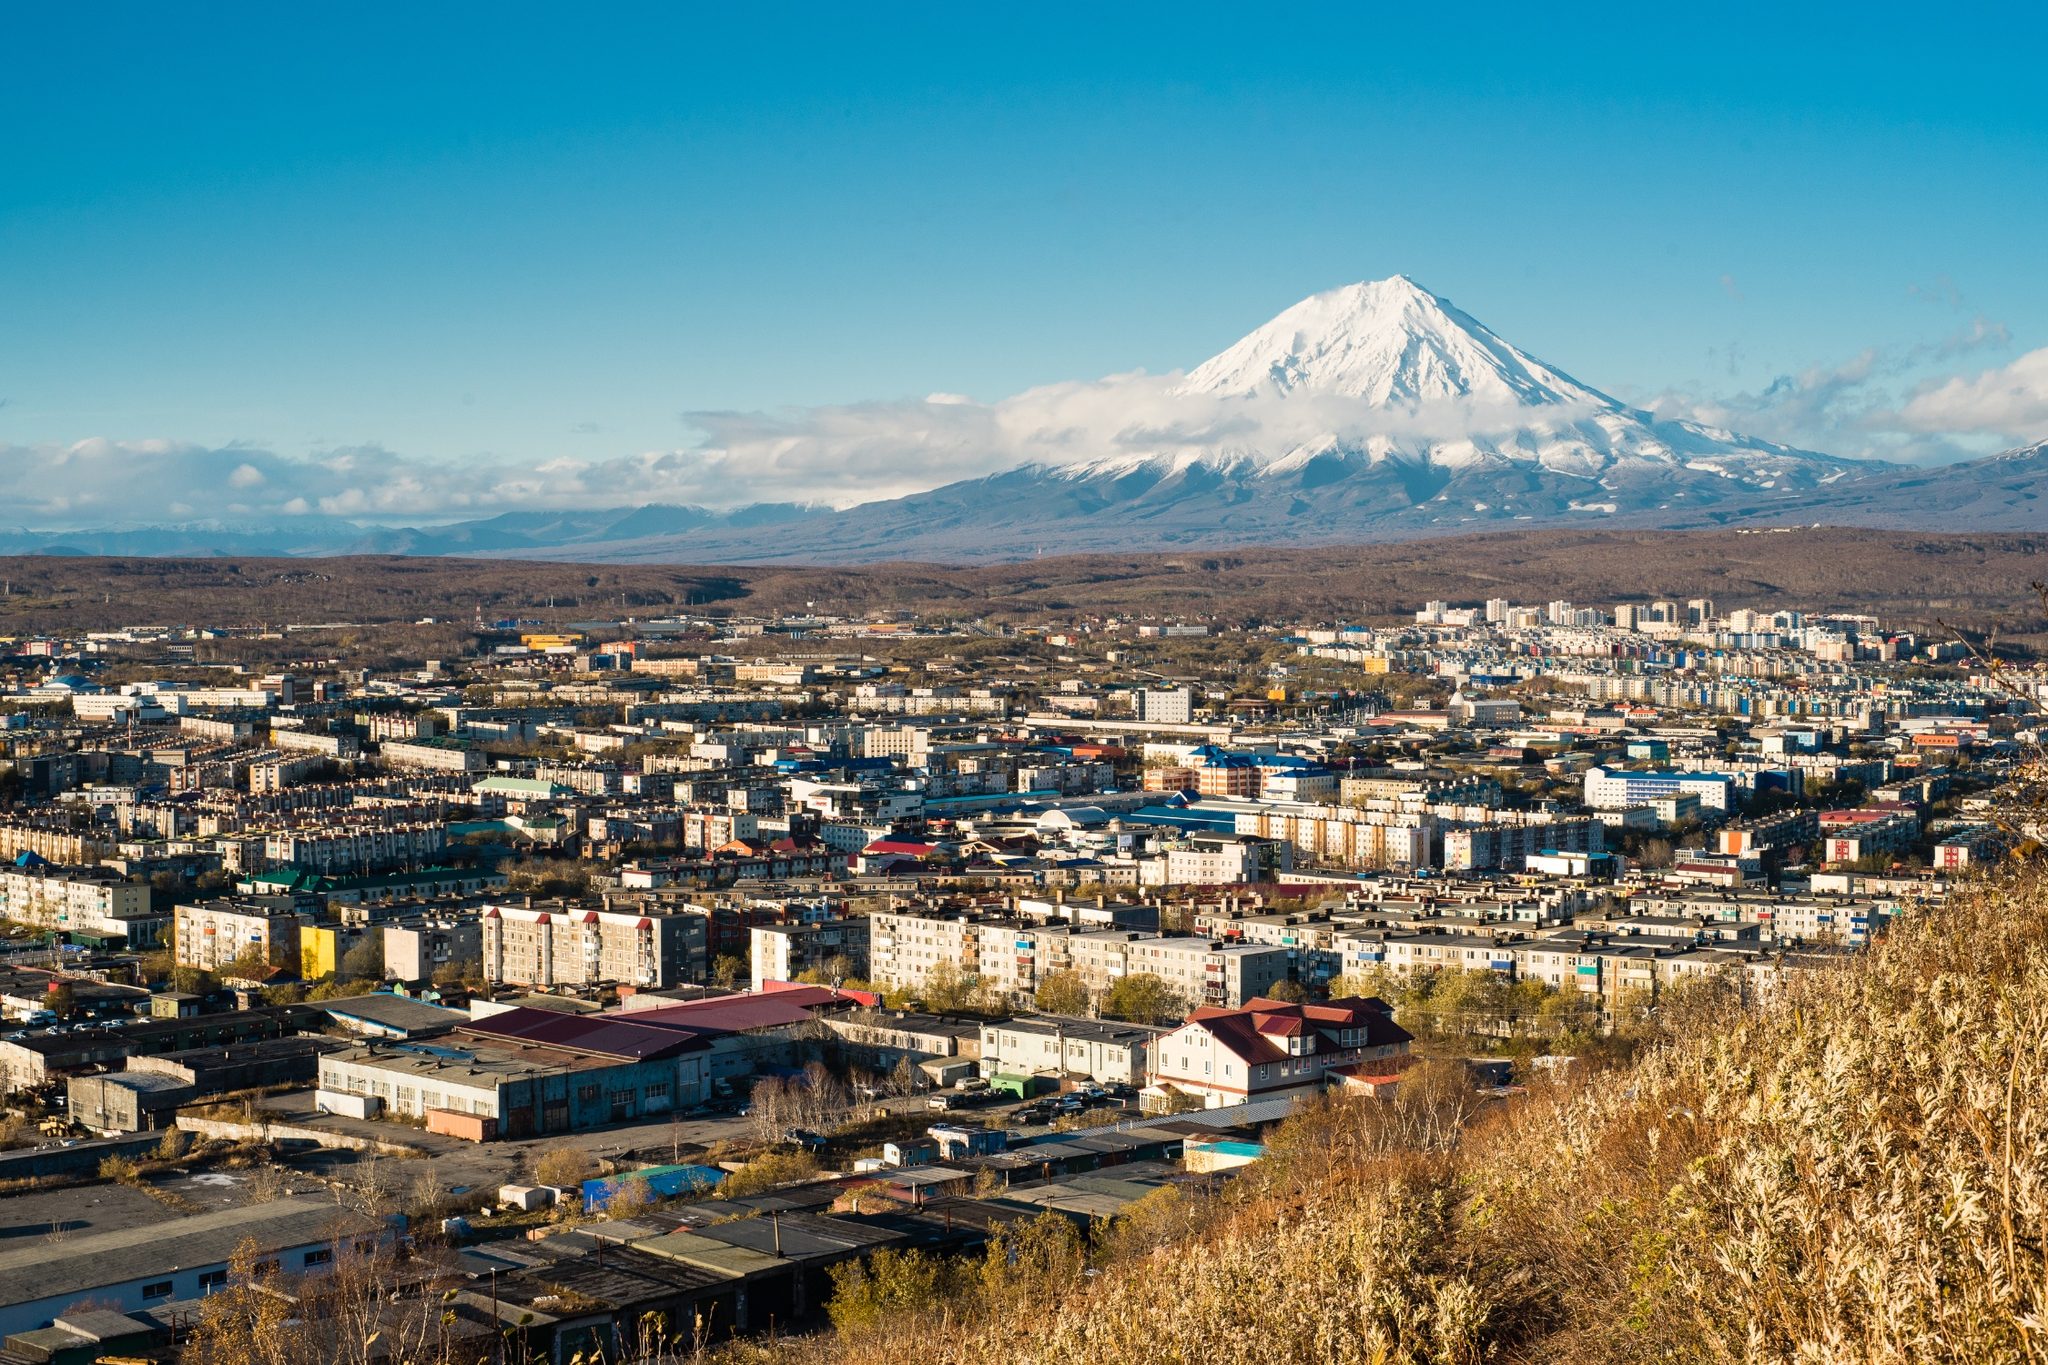Describe a perfect day in Petropavlovsk-Kamchatsky as if from a resident's perspective. A perfect day in Petropavlovsk-Kamchatsky starts with the sun rising over the horizon, casting a golden hue across the cityscape and the towering Koryaksky volcano. I take a morning stroll through the quiet streets, the cool breeze carrying the fresh scent of nature. The market comes alive with vibrant energy, where I encounter familiar faces and exchange warm greetings with neighbors and friends. As the day progresses, I walk to the outskirts, where I can gaze at the snow-capped volcano, its pristine beauty never ceasing to amaze me. In the afternoon, I meet up with friends at a cozy local café, enjoying a rich coffee while sharing stories and laughter. The evening is spent at a scenic viewpoint, watching the sunset paint the sky in hues of orange and pink, with the volcano standing majestically in the backdrop. As the stars dot the night sky, I feel a profound sense of peace and connection to this unique place that beautifully melds urban life with the wild splendor of nature. 